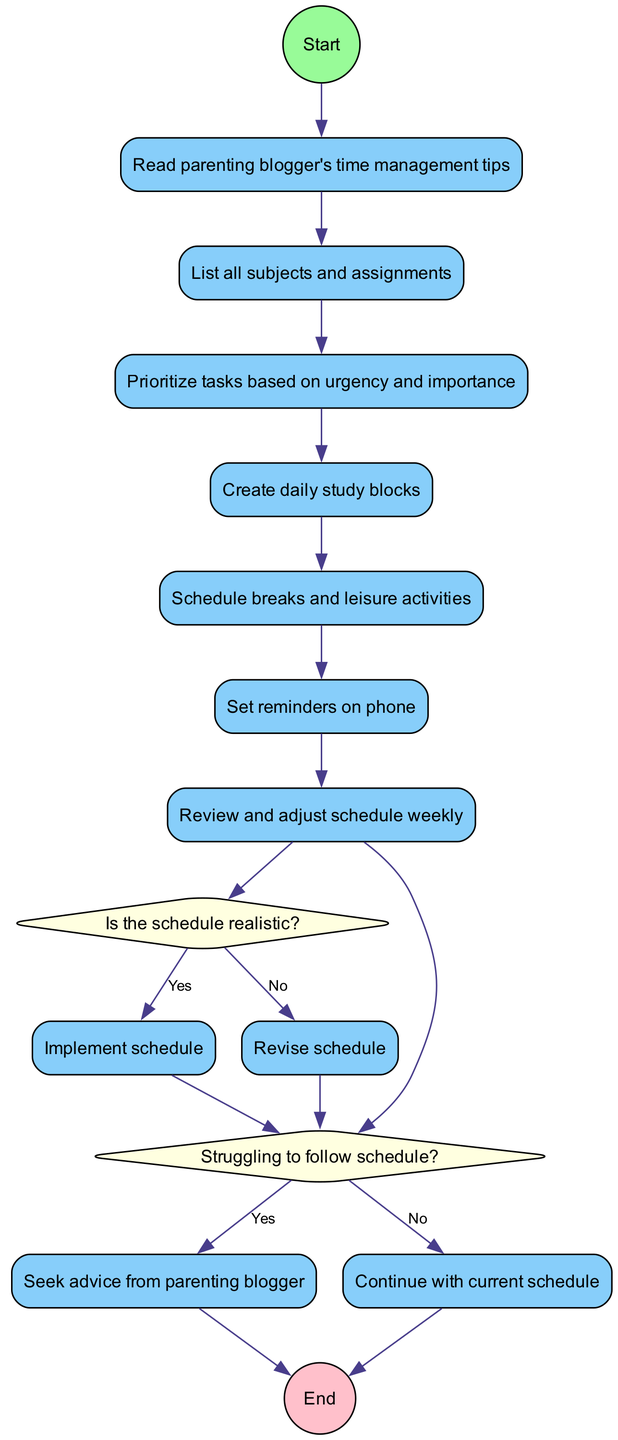What is the first activity in the diagram? The first activity in the diagram is the one that follows the 'Start' node. It states "Read parenting blogger's time management tips."
Answer: Read parenting blogger's time management tips How many activities are there in total? By counting each activity listed after the 'Start' node and before the decision nodes, there are six activities highlighted in the diagram.
Answer: 6 What decision follows the last activity? The decision node follows the last activity in the sequence, and it poses the question, "Is the schedule realistic?"
Answer: Is the schedule realistic? What happens if the schedule is not realistic? If the answer to the question "Is the schedule realistic?" is "No", the diagram indicates to "Revise schedule" as the next step.
Answer: Revise schedule What are the two outcomes of the decision regarding struggling to follow the schedule? After the decision "Struggling to follow schedule?", the two outcomes are "Seek advice from parenting blogger" if "Yes" and "Continue with current schedule" if "No."
Answer: Seek advice from parenting blogger, Continue with current schedule Which node connects the first activity to the first decision? The first decision node is connected to the first activity node through an edge, specifically from "Create daily study blocks" to "Is the schedule realistic?"
Answer: Is the schedule realistic? What shape represents the decision nodes? The decision nodes are represented by a diamond shape, which visually indicates a branching point for possible outcomes based on yes or no answers.
Answer: Diamond What is the final node labeled as? The final node in the diagram is labeled as "End," indicating the conclusion of the process.
Answer: End 